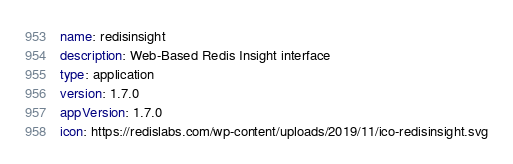Convert code to text. <code><loc_0><loc_0><loc_500><loc_500><_YAML_>name: redisinsight
description: Web-Based Redis Insight interface
type: application
version: 1.7.0
appVersion: 1.7.0
icon: https://redislabs.com/wp-content/uploads/2019/11/ico-redisinsight.svg
</code> 